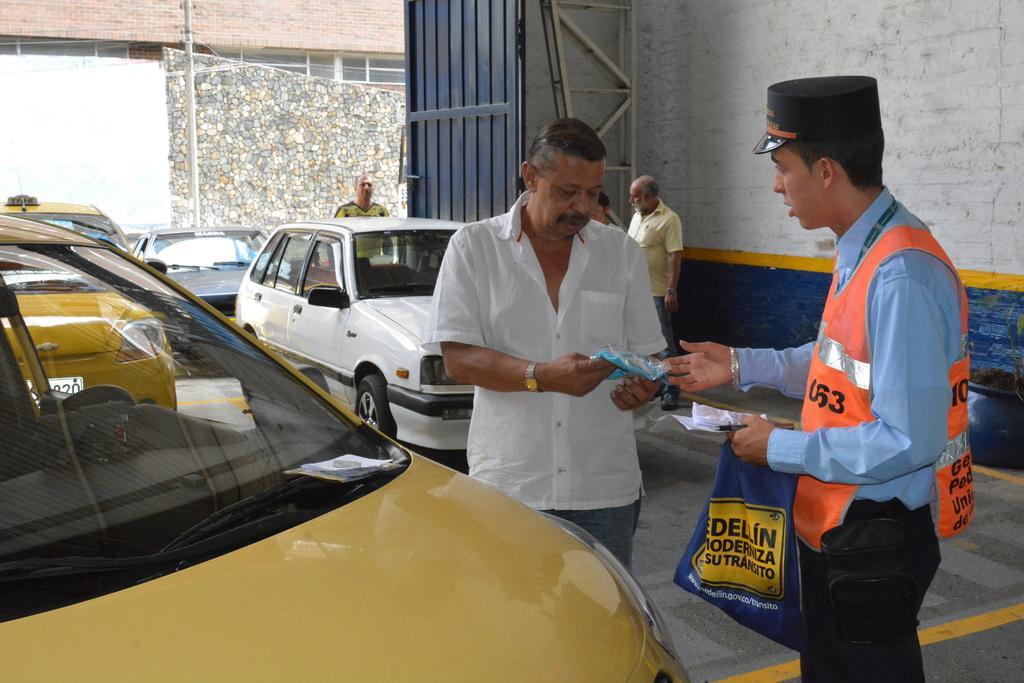Can you describe this image briefly? In the foreground of the picture there are two persons and a car. In the background there are cars, people, gate and wall. In the background there is a building and a current pole. 